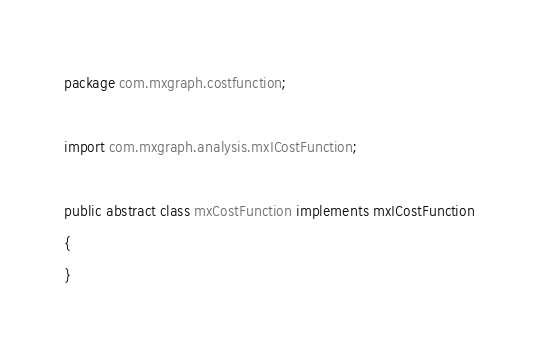Convert code to text. <code><loc_0><loc_0><loc_500><loc_500><_Java_>package com.mxgraph.costfunction;

import com.mxgraph.analysis.mxICostFunction;

public abstract class mxCostFunction implements mxICostFunction
{
}
</code> 